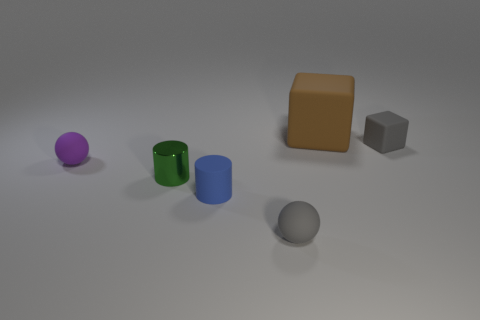Add 2 matte balls. How many objects exist? 8 Subtract all spheres. How many objects are left? 4 Subtract all purple matte balls. Subtract all small green objects. How many objects are left? 4 Add 2 tiny things. How many tiny things are left? 7 Add 2 cylinders. How many cylinders exist? 4 Subtract 0 red blocks. How many objects are left? 6 